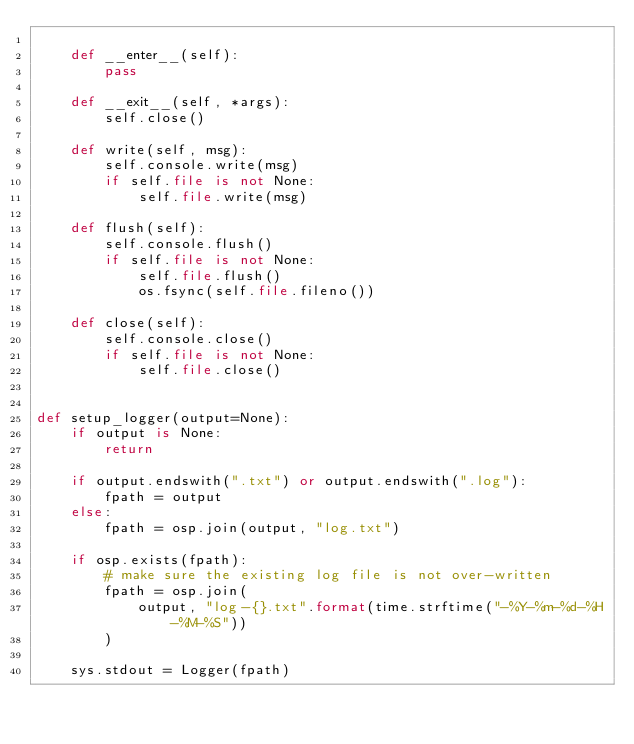Convert code to text. <code><loc_0><loc_0><loc_500><loc_500><_Python_>
    def __enter__(self):
        pass

    def __exit__(self, *args):
        self.close()

    def write(self, msg):
        self.console.write(msg)
        if self.file is not None:
            self.file.write(msg)

    def flush(self):
        self.console.flush()
        if self.file is not None:
            self.file.flush()
            os.fsync(self.file.fileno())

    def close(self):
        self.console.close()
        if self.file is not None:
            self.file.close()


def setup_logger(output=None):
    if output is None:
        return

    if output.endswith(".txt") or output.endswith(".log"):
        fpath = output
    else:
        fpath = osp.join(output, "log.txt")

    if osp.exists(fpath):
        # make sure the existing log file is not over-written
        fpath = osp.join(
            output, "log-{}.txt".format(time.strftime("-%Y-%m-%d-%H-%M-%S"))
        )

    sys.stdout = Logger(fpath)
</code> 